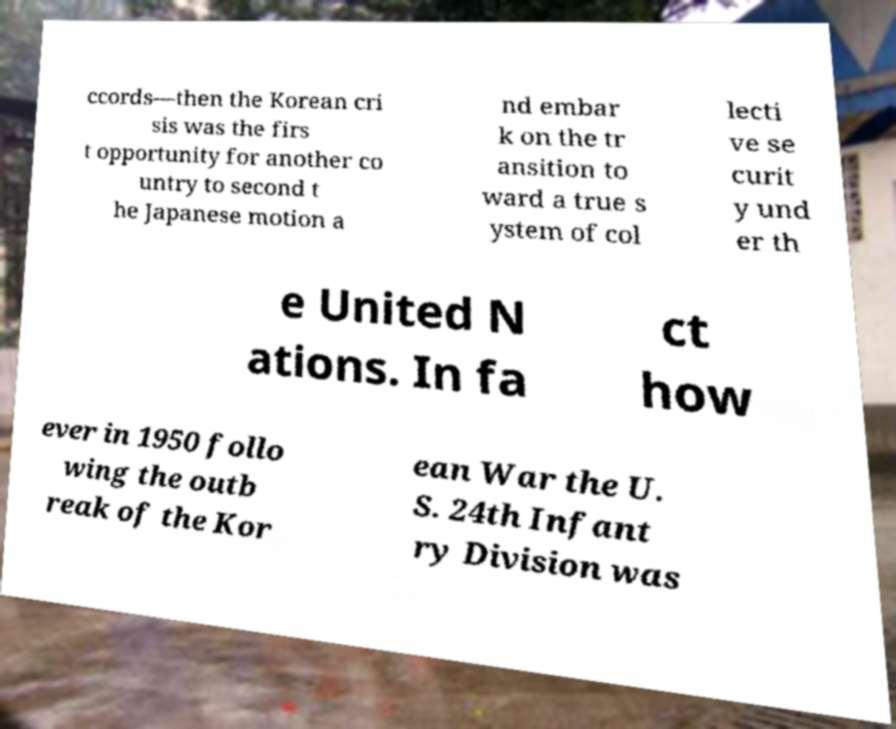Could you extract and type out the text from this image? ccords—then the Korean cri sis was the firs t opportunity for another co untry to second t he Japanese motion a nd embar k on the tr ansition to ward a true s ystem of col lecti ve se curit y und er th e United N ations. In fa ct how ever in 1950 follo wing the outb reak of the Kor ean War the U. S. 24th Infant ry Division was 